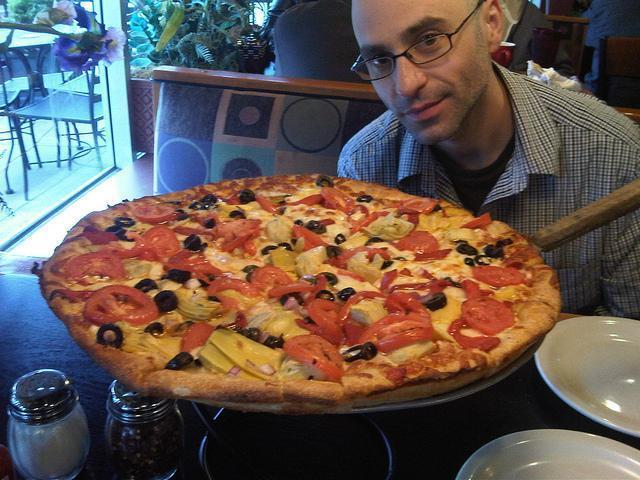How many chairs are there?
Give a very brief answer. 2. How many dining tables are there?
Give a very brief answer. 2. How many people are there?
Give a very brief answer. 2. How many ski poles are to the right of the skier?
Give a very brief answer. 0. 